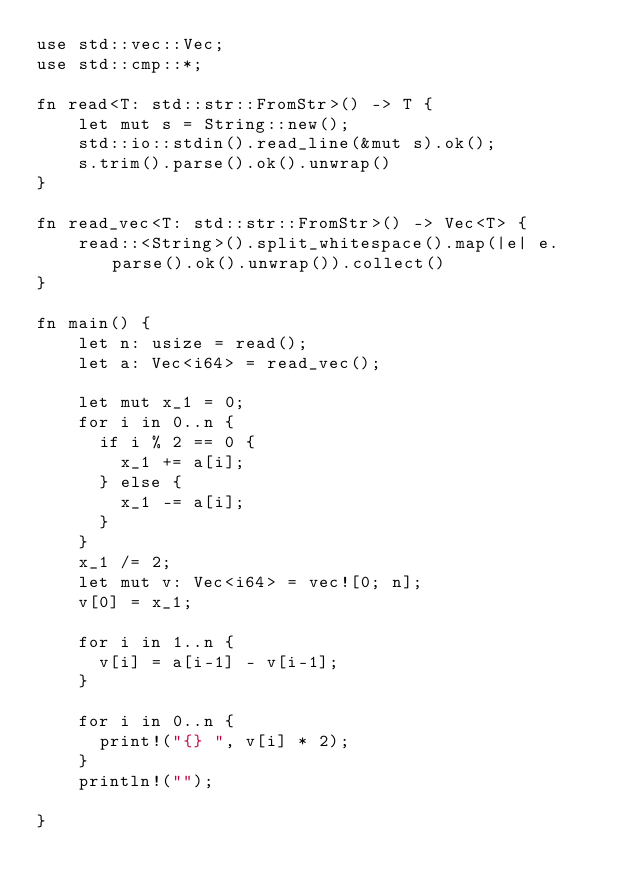<code> <loc_0><loc_0><loc_500><loc_500><_Rust_>use std::vec::Vec;
use std::cmp::*;

fn read<T: std::str::FromStr>() -> T {
    let mut s = String::new();
    std::io::stdin().read_line(&mut s).ok();
    s.trim().parse().ok().unwrap()
}

fn read_vec<T: std::str::FromStr>() -> Vec<T> {
    read::<String>().split_whitespace().map(|e| e.parse().ok().unwrap()).collect()
}

fn main() {
    let n: usize = read();
    let a: Vec<i64> = read_vec();

    let mut x_1 = 0;
    for i in 0..n {
      if i % 2 == 0 {
        x_1 += a[i];
      } else {
        x_1 -= a[i];
      }
    }
    x_1 /= 2;
    let mut v: Vec<i64> = vec![0; n];
    v[0] = x_1;

    for i in 1..n {
      v[i] = a[i-1] - v[i-1];
    }

    for i in 0..n {
      print!("{} ", v[i] * 2);
    }
    println!("");

}
</code> 